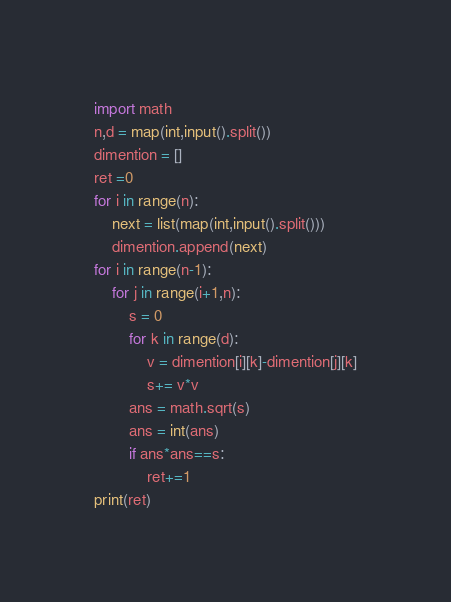Convert code to text. <code><loc_0><loc_0><loc_500><loc_500><_Python_>import math
n,d = map(int,input().split())
dimention = []
ret =0
for i in range(n):
    next = list(map(int,input().split()))
    dimention.append(next)
for i in range(n-1):
    for j in range(i+1,n):
        s = 0
        for k in range(d):
            v = dimention[i][k]-dimention[j][k]
            s+= v*v
        ans = math.sqrt(s)
        ans = int(ans)
        if ans*ans==s:
            ret+=1
print(ret)</code> 